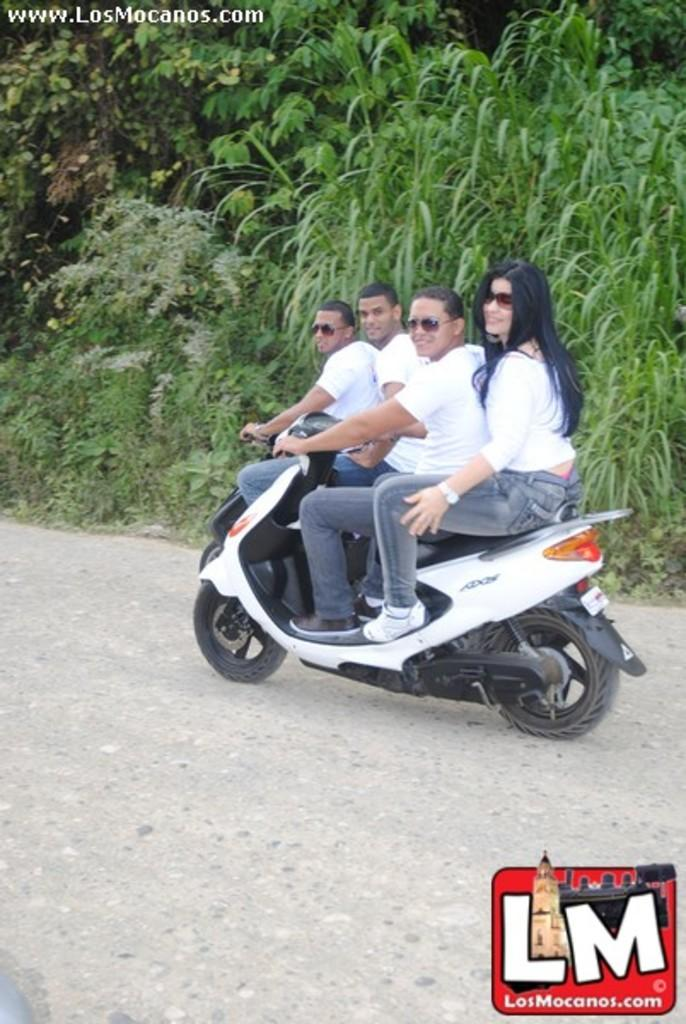What activity are the people in the image engaged in? The people in the image are riding bikes. Where are the people riding bikes? The people are riding bikes on a road. What type of natural elements can be seen in the image? There are plants and trees in the image. Can you tell me how the fog affects the visibility of the people riding bikes in the image? There is no mention of fog in the image, so it cannot be determined how it might affect visibility. --- Facts: 1. There is a person holding a camera in the image. 2. The person is standing on a bridge. 3. There is a river visible in the image. 4. The sky is visible in the image. Absurd Topics: parrot, sand, umbrella Conversation: What is the person in the image holding? The person in the image is holding a camera. Where is the person standing in the image? The person is standing on a bridge. What type of natural element can be seen in the image? There is a river visible in the image. What is visible at the top of the image? The sky is visible in the image. Reasoning: Let's think step by step in order to produce the conversation. We start by identifying the main subject in the image, which is the person holding a camera. Then, we expand the conversation to include the location of the person, which is on a bridge. Finally, we describe the natural elements present in the image, which are a river and the sky. Absurd Question/Answer: Can you tell me how many parrots are sitting on the sand in the image? There are no parrots or sand present in the image. Is there an umbrella visible in the image? There is no mention of an umbrella in the image. 